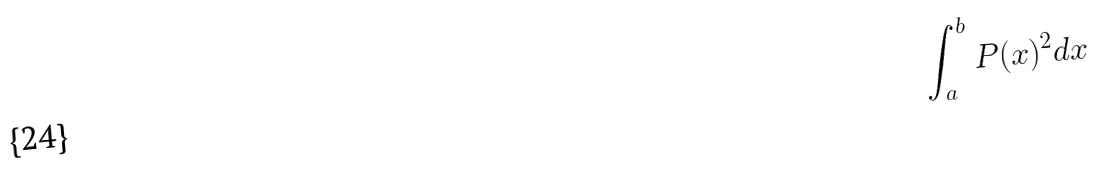Convert formula to latex. <formula><loc_0><loc_0><loc_500><loc_500>\int _ { a } ^ { b } P ( x ) ^ { 2 } d x</formula> 